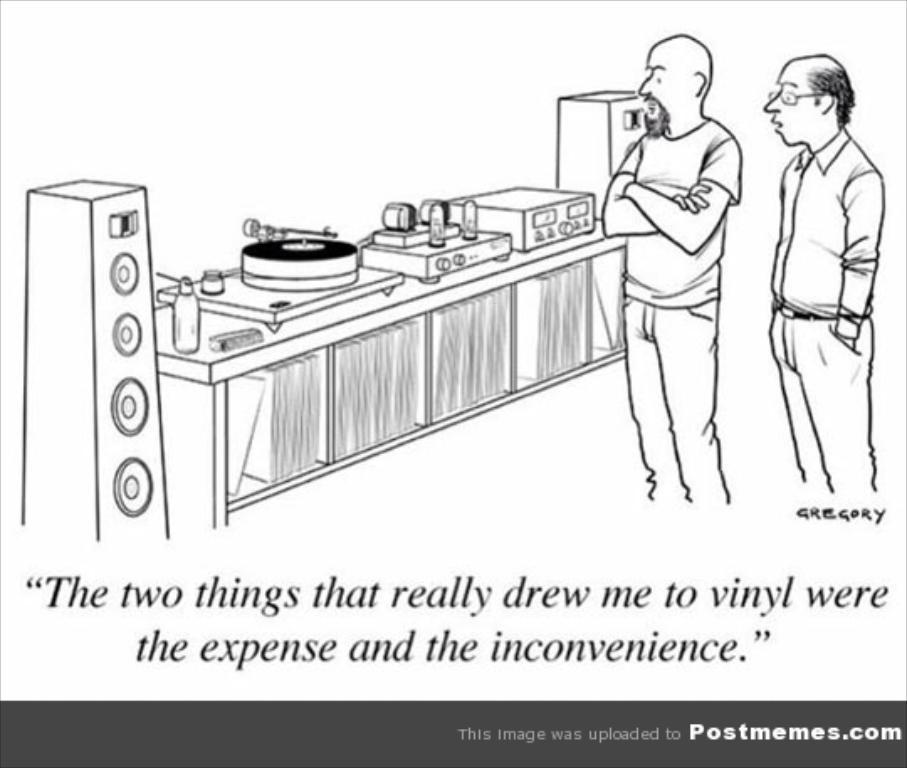Please provide a concise description of this image. In this image we can see the sketch and some text at the bottom. 